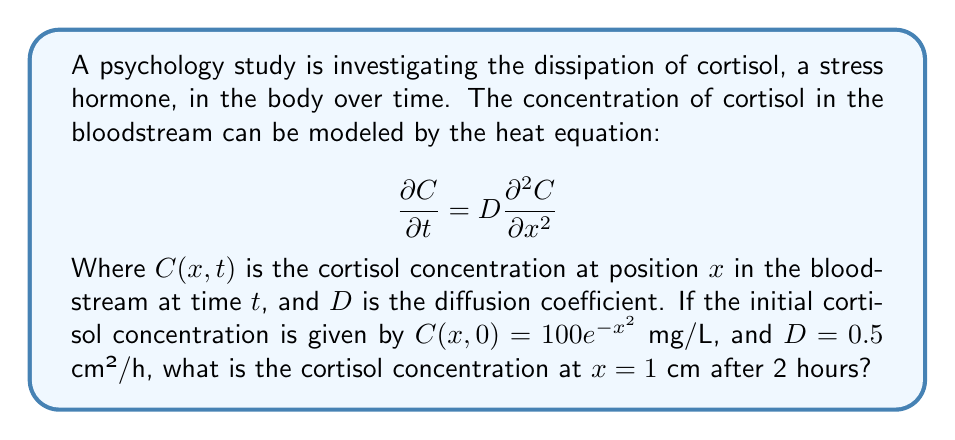Solve this math problem. To solve this problem, we'll use the fundamental solution of the heat equation:

1) The general solution for the 1D heat equation with initial condition $C(x,0) = f(x)$ is:

   $$C(x,t) = \frac{1}{\sqrt{4\pi Dt}} \int_{-\infty}^{\infty} f(\xi) e^{-\frac{(x-\xi)^2}{4Dt}} d\xi$$

2) In our case, $f(x) = 100e^{-x^2}$, $D = 0.5$ cm²/h, $t = 2$ h, and we want to find $C(1,2)$.

3) Substituting these values into the solution:

   $$C(1,2) = \frac{1}{\sqrt{4\pi (0.5)(2)}} \int_{-\infty}^{\infty} 100e^{-\xi^2} e^{-\frac{(1-\xi)^2}{4(0.5)(2)}} d\xi$$

4) Simplify:

   $$C(1,2) = \frac{100}{\sqrt{2\pi}} \int_{-\infty}^{\infty} e^{-\xi^2} e^{-\frac{(1-\xi)^2}{4}} d\xi$$

5) This integral can be solved using the convolution of Gaussians formula:

   $$\int_{-\infty}^{\infty} e^{-ax^2} e^{-b(y-x)^2} dx = \sqrt{\frac{\pi}{a+b}} e^{-\frac{ab}{a+b}y^2}$$

6) In our case, $a=1$, $b=1/4$, and $y=1$. Applying the formula:

   $$C(1,2) = \frac{100}{\sqrt{2\pi}} \sqrt{\frac{\pi}{1+1/4}} e^{-\frac{1(1/4)}{1+1/4}(1)^2}$$

7) Simplify:

   $$C(1,2) = 100 \sqrt{\frac{4}{5}} e^{-1/5} \approx 71.65 \text{ mg/L}$$
Answer: $71.65$ mg/L 